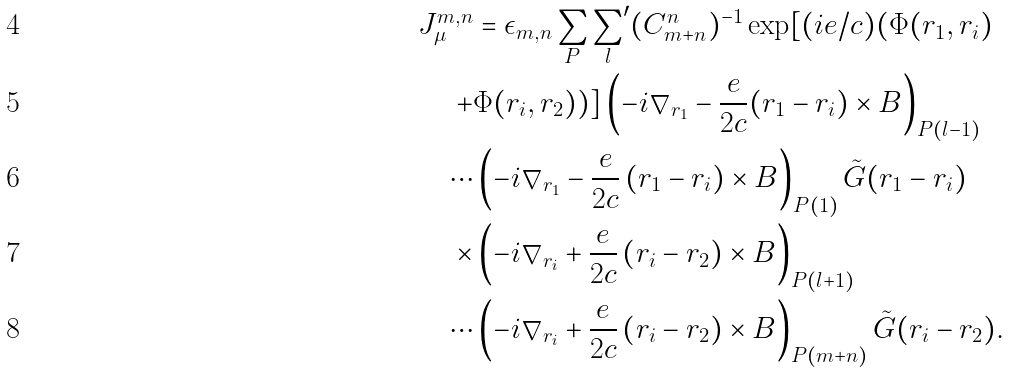<formula> <loc_0><loc_0><loc_500><loc_500>J _ { \mu } ^ { m , n } & = \epsilon _ { m , n } \sum _ { P } { \sum _ { l } } ^ { \prime } ( C ^ { n } _ { m + n } ) ^ { - 1 } \exp [ ( i e / c ) ( \Phi ( { r } _ { 1 } , { r } _ { i } ) \\ + & \Phi ( { r } _ { i } , { r } _ { 2 } ) ) ] \left ( - i \nabla _ { { r } _ { 1 } } - \frac { e } { 2 c } ( { r } _ { 1 } - { r } _ { i } ) \times { B } \right ) _ { P ( l - 1 ) } \\ \cdots & \left ( - i \nabla _ { { r } _ { 1 } } - \frac { e } { 2 c } \left ( { r } _ { 1 } - { r } _ { i } \right ) \times { B } \right ) _ { P ( 1 ) } \tilde { G } ( { r } _ { 1 } - { r } _ { i } ) \\ \times & \left ( - i \nabla _ { { r } _ { i } } + \frac { e } { 2 c } \left ( { r } _ { i } - { r } _ { 2 } \right ) \times { B } \right ) _ { P ( l + 1 ) } \\ \cdots & \left ( - i \nabla _ { { r } _ { i } } + \frac { e } { 2 c } \left ( { r } _ { i } - { r } _ { 2 } \right ) \times { B } \right ) _ { P ( m + n ) } \tilde { G } ( { r } _ { i } - { r } _ { 2 } ) .</formula> 